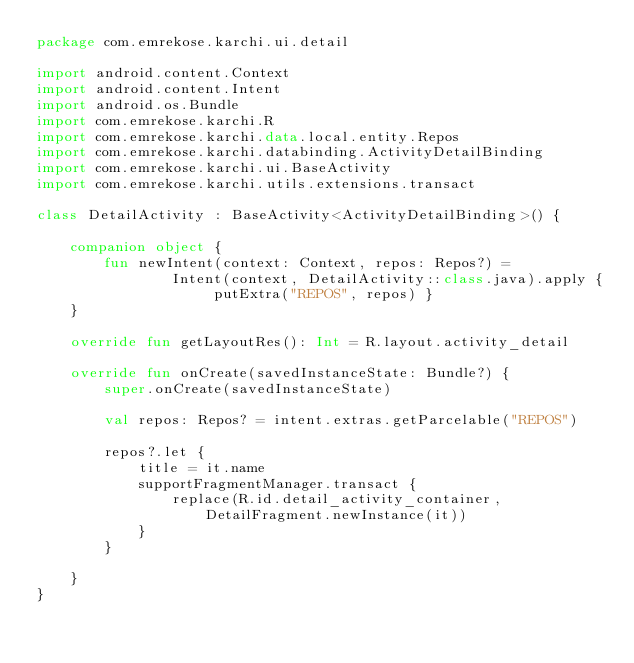Convert code to text. <code><loc_0><loc_0><loc_500><loc_500><_Kotlin_>package com.emrekose.karchi.ui.detail

import android.content.Context
import android.content.Intent
import android.os.Bundle
import com.emrekose.karchi.R
import com.emrekose.karchi.data.local.entity.Repos
import com.emrekose.karchi.databinding.ActivityDetailBinding
import com.emrekose.karchi.ui.BaseActivity
import com.emrekose.karchi.utils.extensions.transact

class DetailActivity : BaseActivity<ActivityDetailBinding>() {

    companion object {
        fun newIntent(context: Context, repos: Repos?) =
                Intent(context, DetailActivity::class.java).apply { putExtra("REPOS", repos) }
    }

    override fun getLayoutRes(): Int = R.layout.activity_detail

    override fun onCreate(savedInstanceState: Bundle?) {
        super.onCreate(savedInstanceState)

        val repos: Repos? = intent.extras.getParcelable("REPOS")

        repos?.let {
            title = it.name
            supportFragmentManager.transact {
                replace(R.id.detail_activity_container, DetailFragment.newInstance(it))
            }
        }

    }
}
</code> 